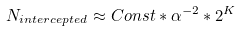<formula> <loc_0><loc_0><loc_500><loc_500>N _ { i n t e r c e p t e d } \approx C o n s t * \alpha ^ { - 2 } * 2 ^ { K }</formula> 